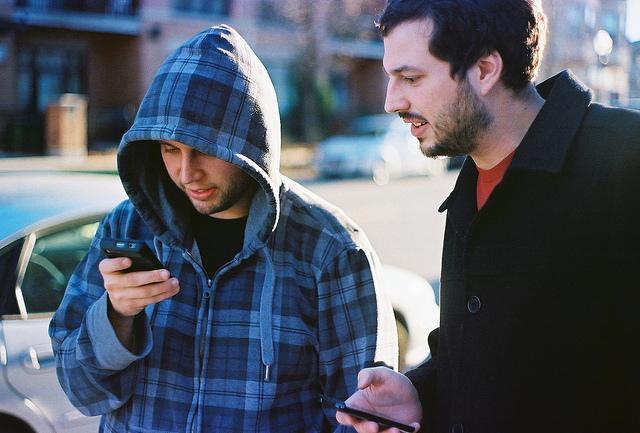How many cars are there?
Give a very brief answer. 2. How many people are there?
Give a very brief answer. 2. How many cows are photographed?
Give a very brief answer. 0. 